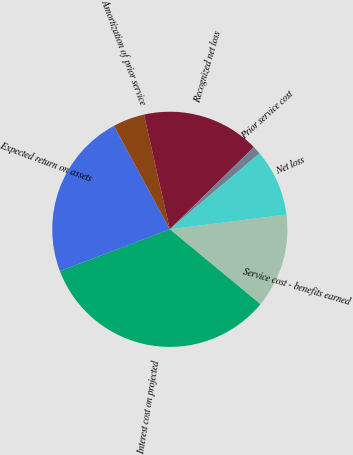Convert chart to OTSL. <chart><loc_0><loc_0><loc_500><loc_500><pie_chart><fcel>Service cost - benefits earned<fcel>Interest cost on projected<fcel>Expected return on assets<fcel>Amortization of prior service<fcel>Recognized net loss<fcel>Prior service cost<fcel>Net loss<nl><fcel>12.99%<fcel>33.22%<fcel>22.9%<fcel>4.36%<fcel>16.19%<fcel>1.15%<fcel>9.18%<nl></chart> 